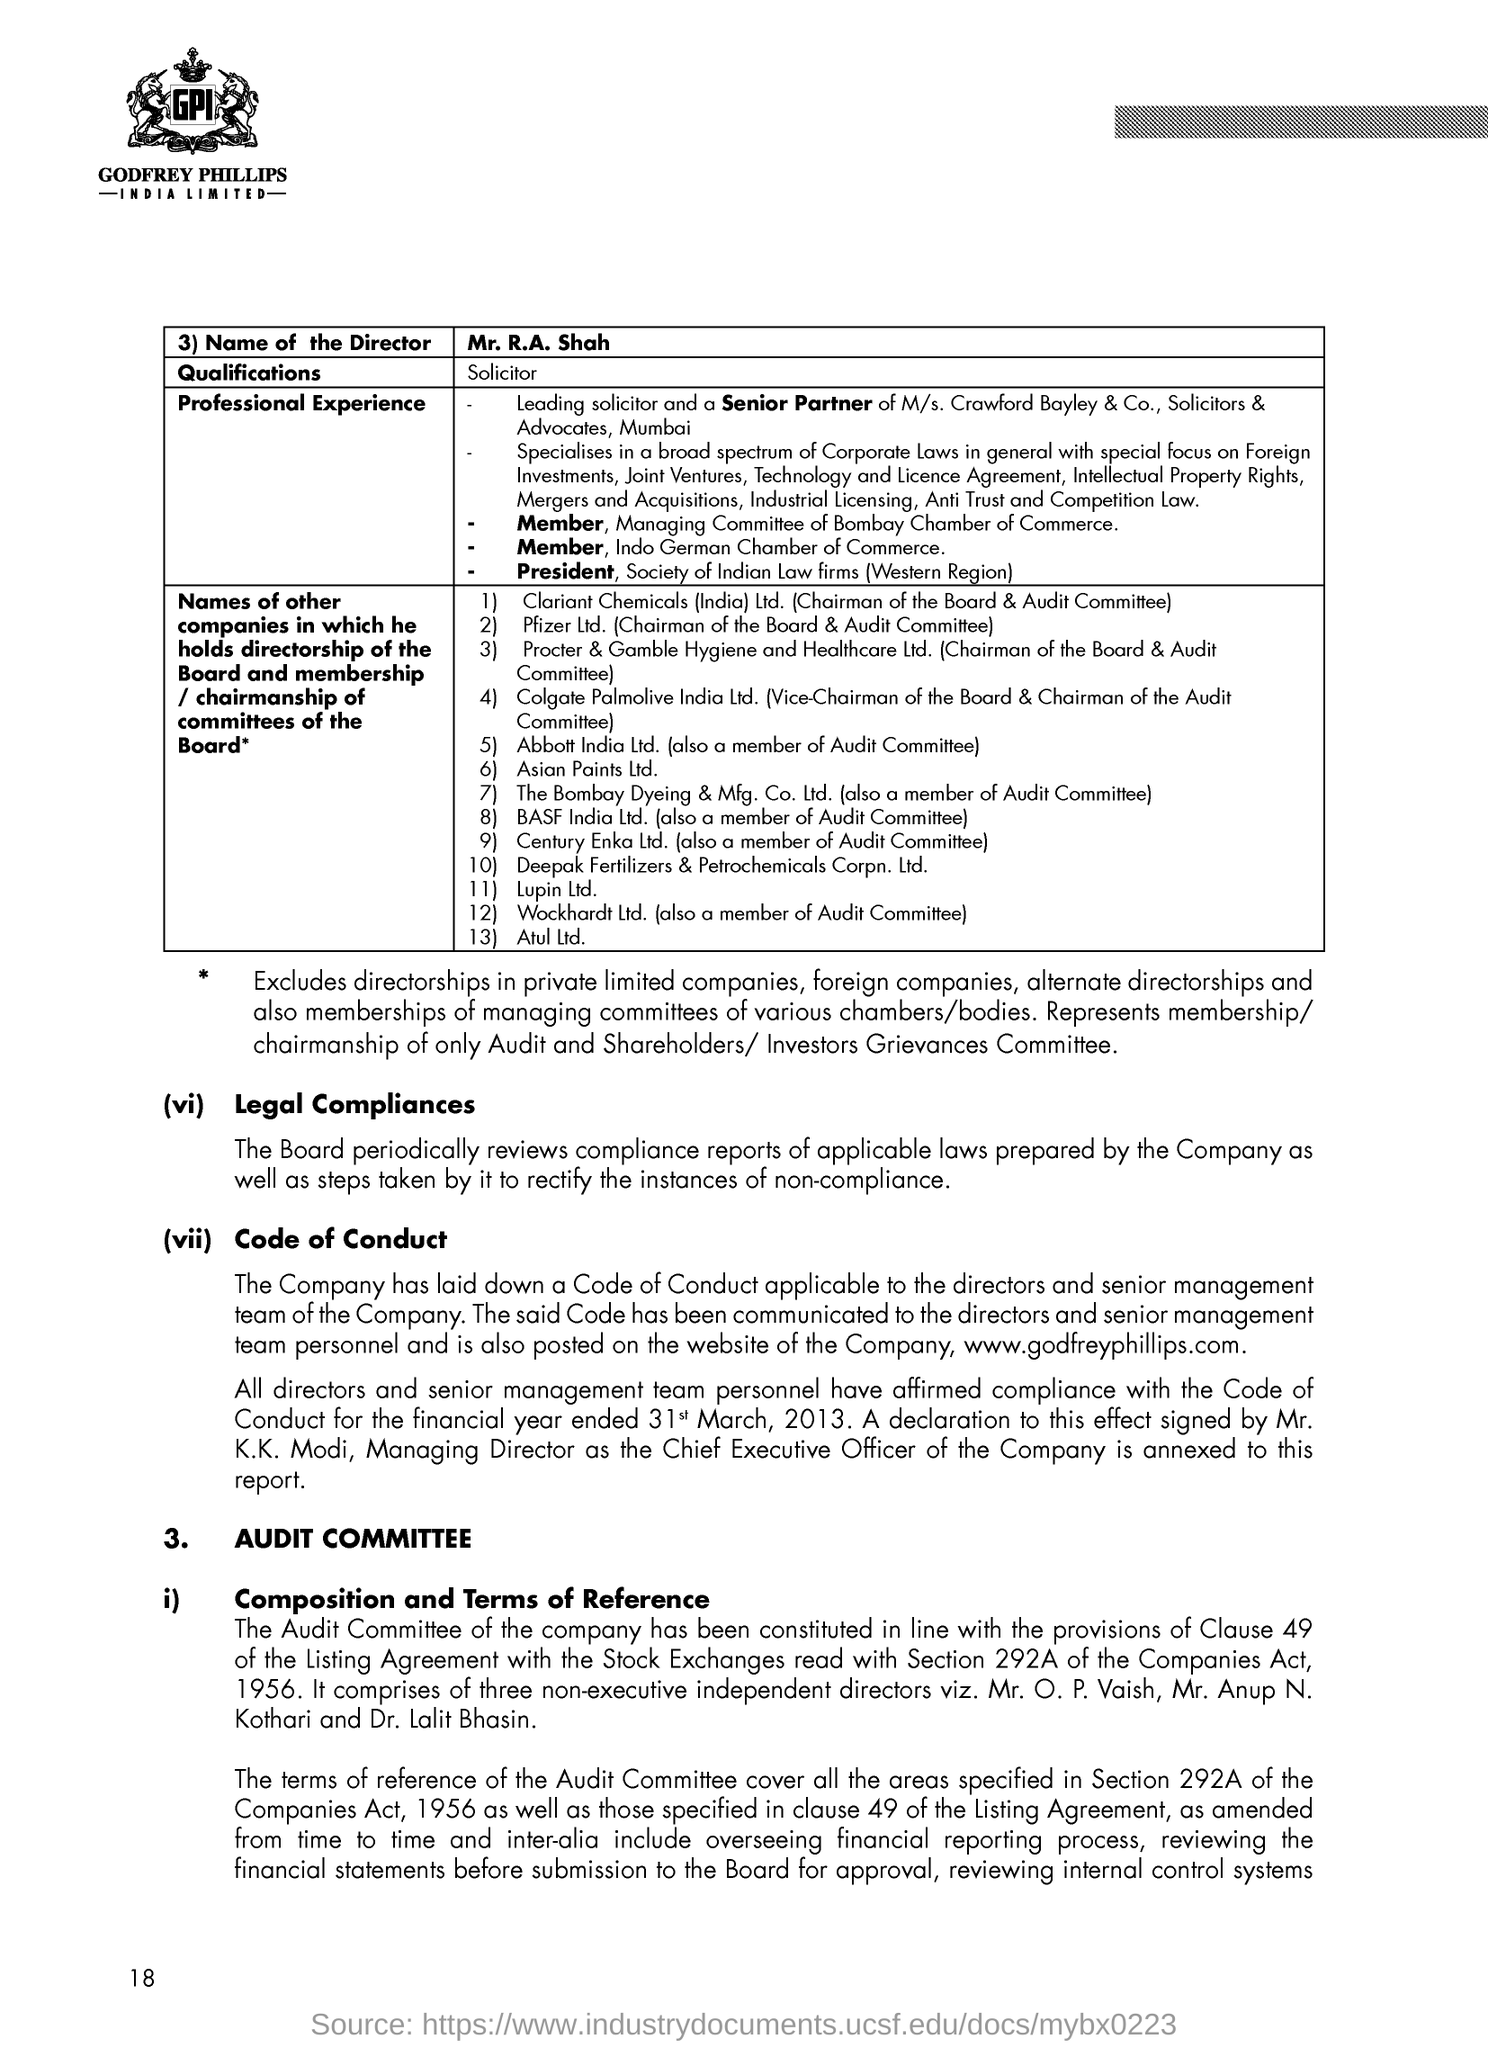Highlight a few significant elements in this photo. The name of the Director is Mr. R.A. Shah. Mr. R.A. Shah is a solicitor. 